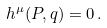Convert formula to latex. <formula><loc_0><loc_0><loc_500><loc_500>h ^ { \mu } ( P , q ) = 0 \, .</formula> 